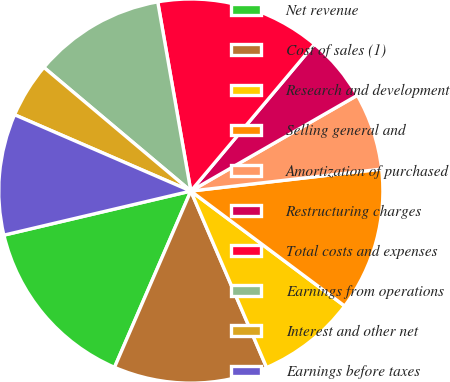Convert chart. <chart><loc_0><loc_0><loc_500><loc_500><pie_chart><fcel>Net revenue<fcel>Cost of sales (1)<fcel>Research and development<fcel>Selling general and<fcel>Amortization of purchased<fcel>Restructuring charges<fcel>Total costs and expenses<fcel>Earnings from operations<fcel>Interest and other net<fcel>Earnings before taxes<nl><fcel>14.81%<fcel>12.96%<fcel>8.33%<fcel>12.04%<fcel>6.48%<fcel>5.56%<fcel>13.89%<fcel>11.11%<fcel>4.63%<fcel>10.19%<nl></chart> 